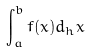Convert formula to latex. <formula><loc_0><loc_0><loc_500><loc_500>\int _ { a } ^ { b } f ( x ) d _ { h } x</formula> 